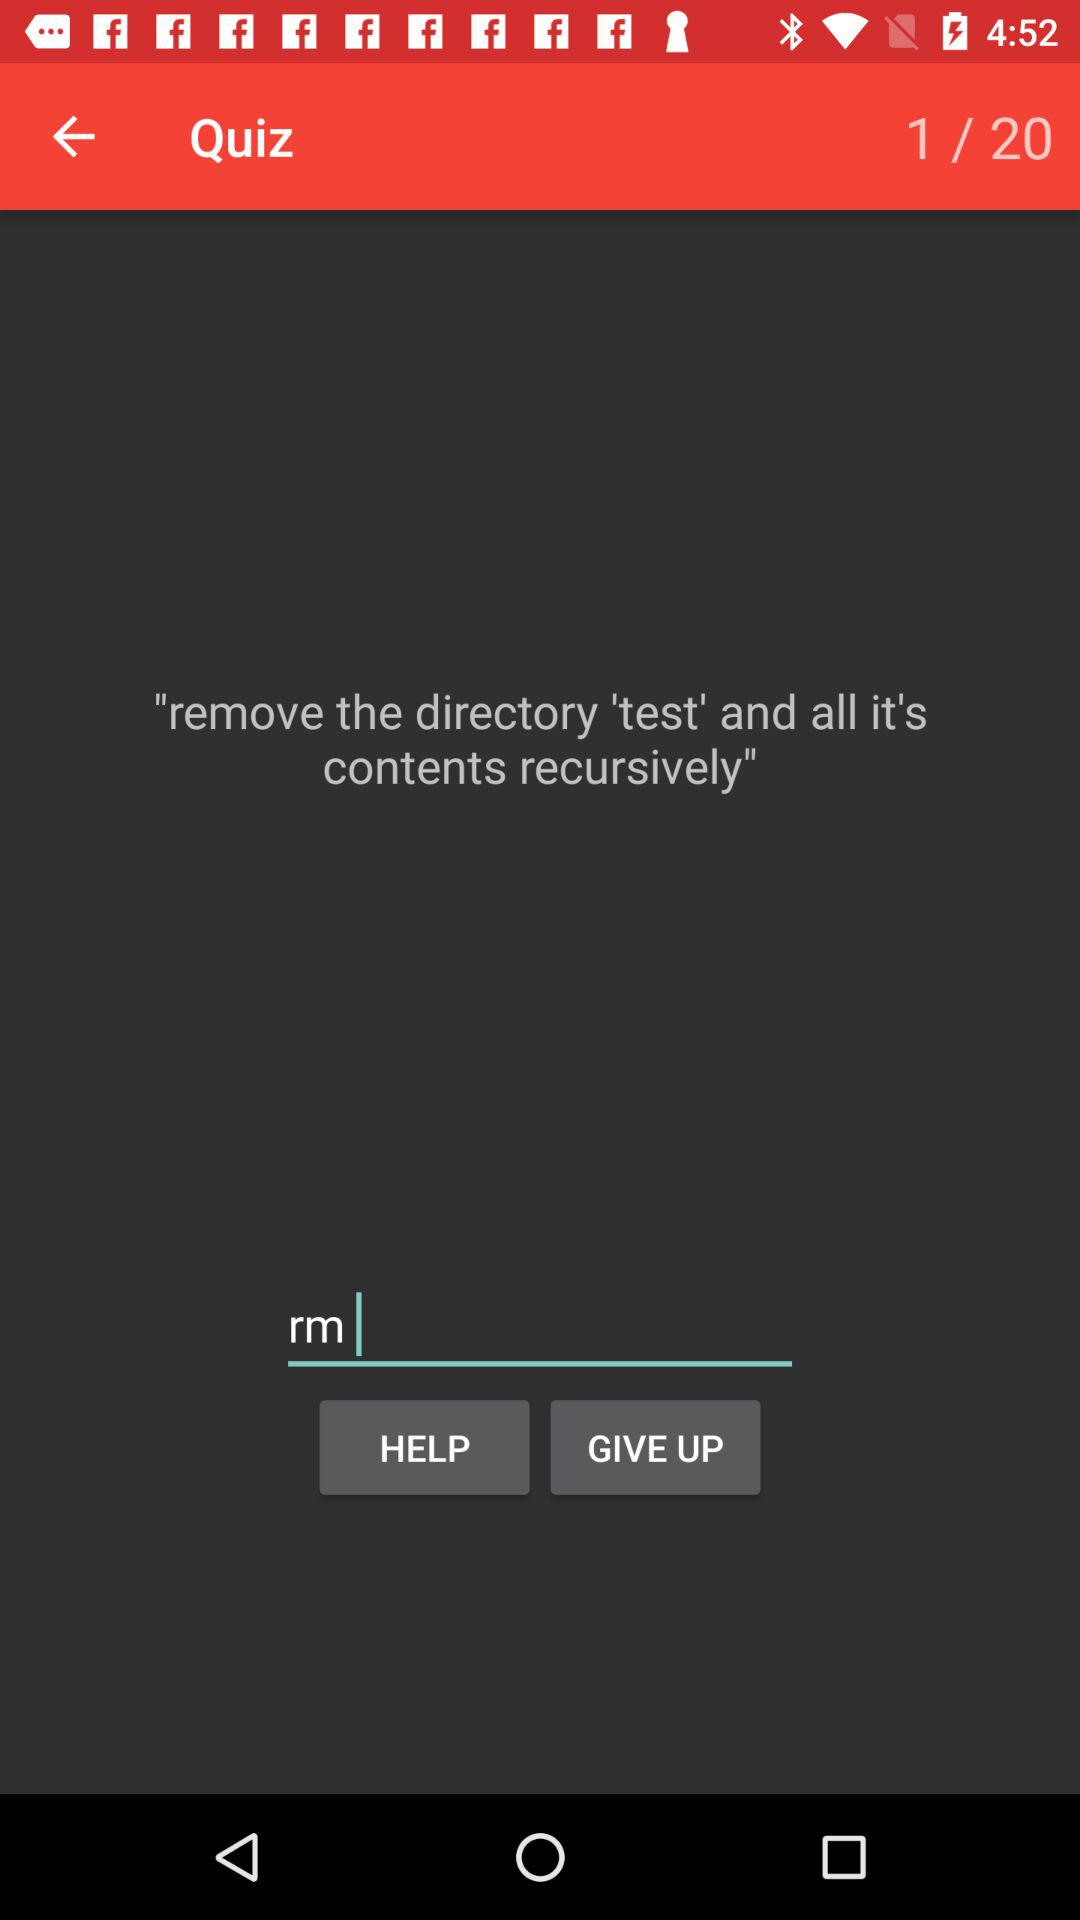How many questions in total are there? There are 20 questions. 